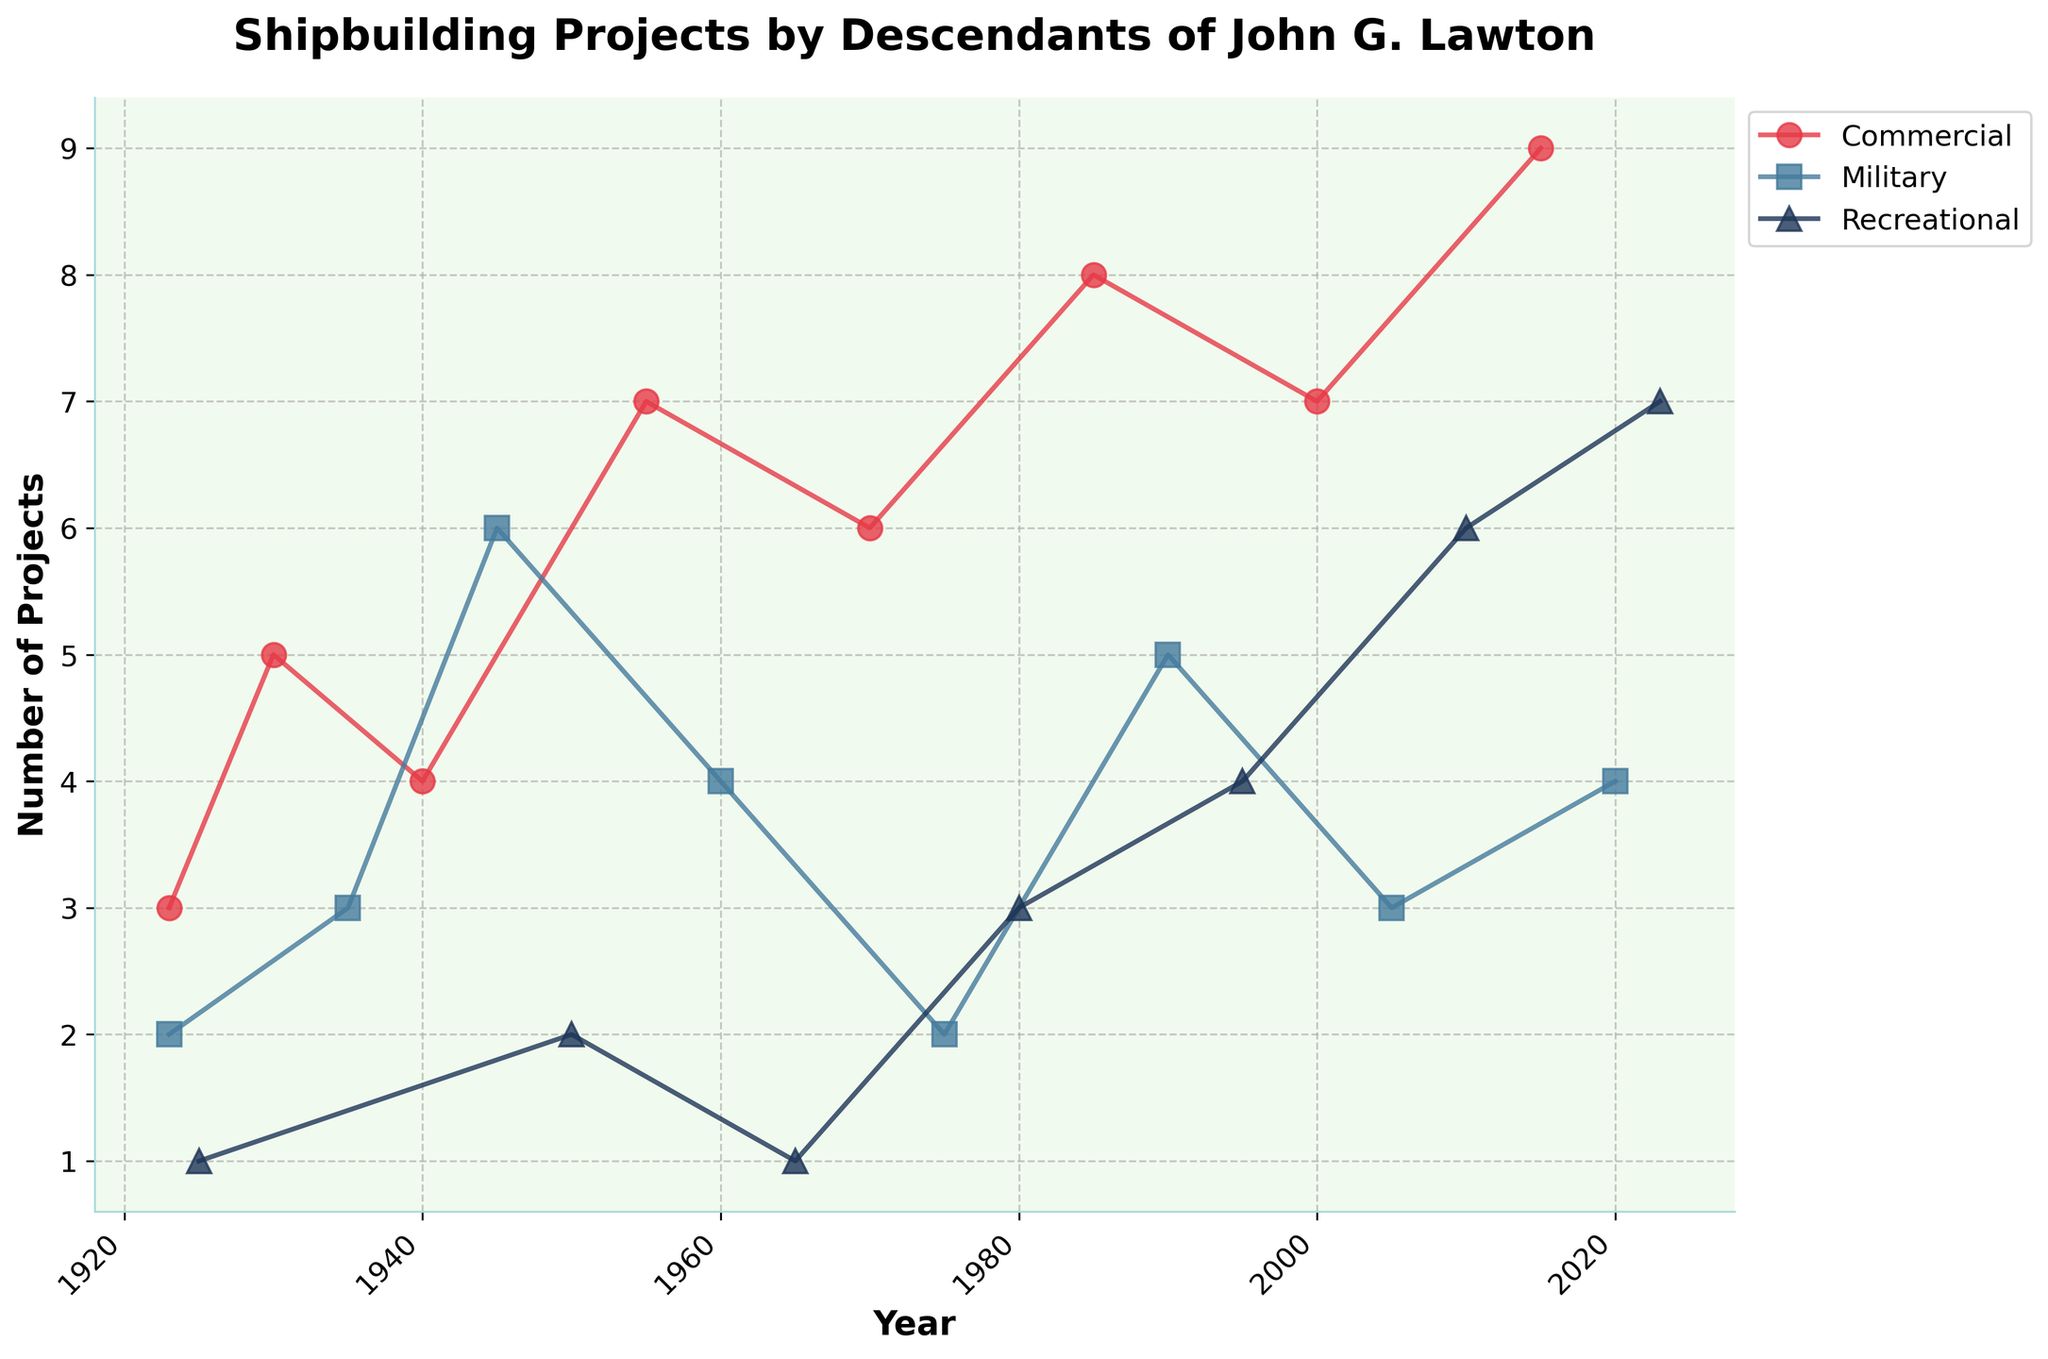What is the title of the plot? The title is located at the top of the plot and provides a brief summary of what the plot represents. Here, it reads "Shipbuilding Projects by Descendants of John G. Lawton."
Answer: Shipbuilding Projects by Descendants of John G. Lawton How many different types of vessels are shown in the plot? By examining the legend or the lines with different colors and markers on the plot, we can identify the three types of vessels: Commercial, Military, and Recreational.
Answer: 3 What is the overall trend in commercial shipbuilding projects over time? By looking at the line representing commercial shipbuilding projects (likely identified by a specific color and marker), we see an overall upward trend, indicating an increase in the number of projects over time.
Answer: Upward What was the highest number of military shipbuilding projects in a single year? Locate the peak or highest point on the line representing military shipbuilding projects. The highest value is 6 projects, which occurred around 1945.
Answer: 6 In which year did recreational shipbuilding projects reach 7? Find the point where the line representing recreational shipbuilding projects hits the value of 7. This occurs in the year 2023.
Answer: 2023 What is the difference in the number of commercial projects between 1985 and 2015? Locate the data points for commercial projects in 1985 and 2015. In 1985, there were 8 projects, and in 2015, there were 9. The difference is 9 - 8 = 1.
Answer: 1 How does the trend of military shipbuilding projects compare to that of recreational projects from 1950 onward? Analyze the lines representing both military and recreational shipbuilding projects from 1950 onward. The military projects show fluctuations but generally decrease, while recreational projects show an upward trend.
Answer: Recreational increases, Military fluctuates/decreases Which type of vessel had the most significant increase in shipbuilding projects over the past 100 years? By comparing the overall trends of the three types of vessels, we see that commercial shipbuilding projects increased the most significantly, from 3 in 1923 to 9 in 2015.
Answer: Commercial In which year did all three types of vessels have projects completed? This would involve looking for a year where all three lines (commercial, military, and recreational) intersect or are present. In the dataset, no single year has all three types present; the closest is 1923.
Answer: 1923 Which vessel type shows the most consistent trend over the years? Observing the lines, commercial projects show a relatively consistent upward trend, while military and recreational projects have more fluctuations.
Answer: Commercial 